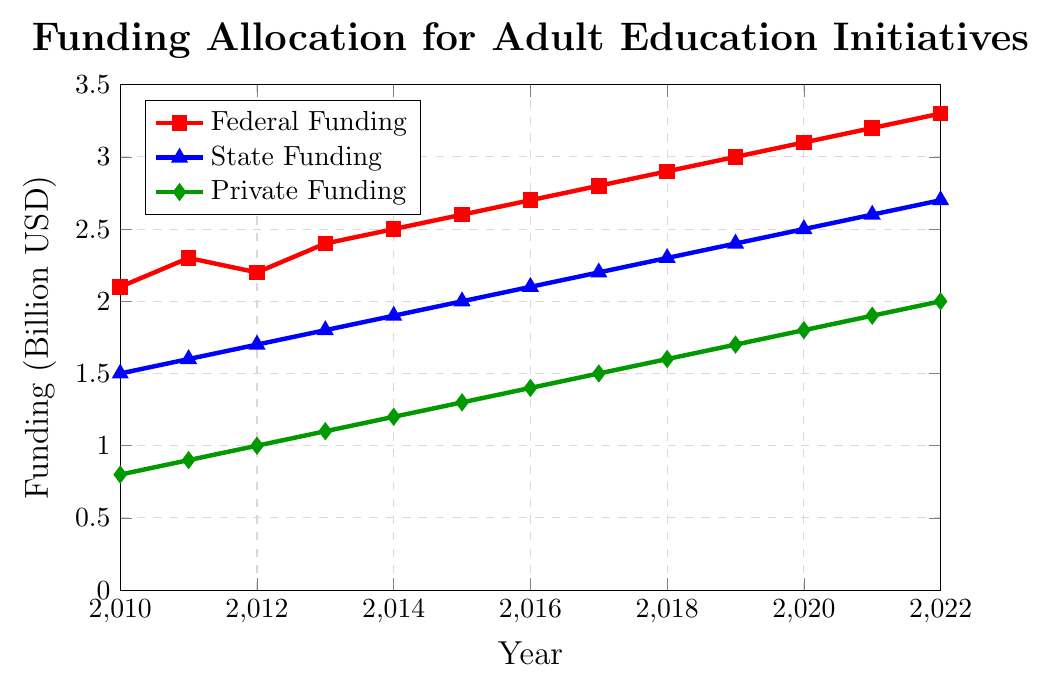What is the funding trend for federal funding from 2010 to 2022? Federal funding has steadily increased from 2.1 billion USD in 2010 to 3.3 billion USD in 2022. Each year, the funding either increased or remained steady, illustrating an overall upward trend.
Answer: Upward trend Which funding source had the highest allocation in 2015? By comparing the lines in the plot for the year 2015, Federal Funding is the highest at approximately 2.6 billion USD. The other sources are lower: State Funding is at 2.0 billion USD, and Private Funding is at 1.3 billion USD.
Answer: Federal Funding In which year did state funding first surpass 2.0 billion USD? Reviewing the plot for State Funding, the line crosses the 2.0 billion USD mark between 2014 and 2015. Therefore, the first year it surpasses 2.0 billion USD is 2015.
Answer: 2015 How much did private funding increase between 2010 and 2022? To calculate the increase in private funding, subtract the private funding in 2010 from that in 2022: 2.0 billion USD (2022) - 0.8 billion USD (2010) = 1.2 billion USD.
Answer: 1.2 billion USD Which year saw the smallest difference between federal and state funding? By examining each year in the plot and calculating the difference, the smallest difference appears between 2010 (0.6 billion USD) and decreases up to 0.5 billion USD in 2022.
Answer: 2022 What is the combined total funding from all sources in 2022? Adding the total funding from each source in 2022: Federal Funding (3.3 billion USD) + State Funding (2.7 billion USD) + Private Funding (2.0 billion USD) = 8.0 billion USD.
Answer: 8.0 billion USD Compare the slope (rate of change) of the federal and private funding lines between 2010 and 2022. Which has a steeper slope? The slope of Federal Funding from 2010 (2.1 billion USD) to 2022 (3.3 billion USD) is (3.3 - 2.1) / (2022 - 2010) = 0.1 billion USD per year. For Private Funding from 2010 (0.8 billion USD) to 2022 (2.0 billion USD), (2.0 - 0.8) / (2022 - 2010) = 0.1 billion USD per year. Both have the same slope.
Answer: Both have the same slope During which years did state funding see the most rapid increase? The line for State Funding shows the most significant visual increase between the years 2010 and 2012, where it rises from 1.5 billion USD to 1.7 billion USD, and between 2019 and 2020 from 2.4 billion USD to 2.5 billion USD.
Answer: 2019-2020 